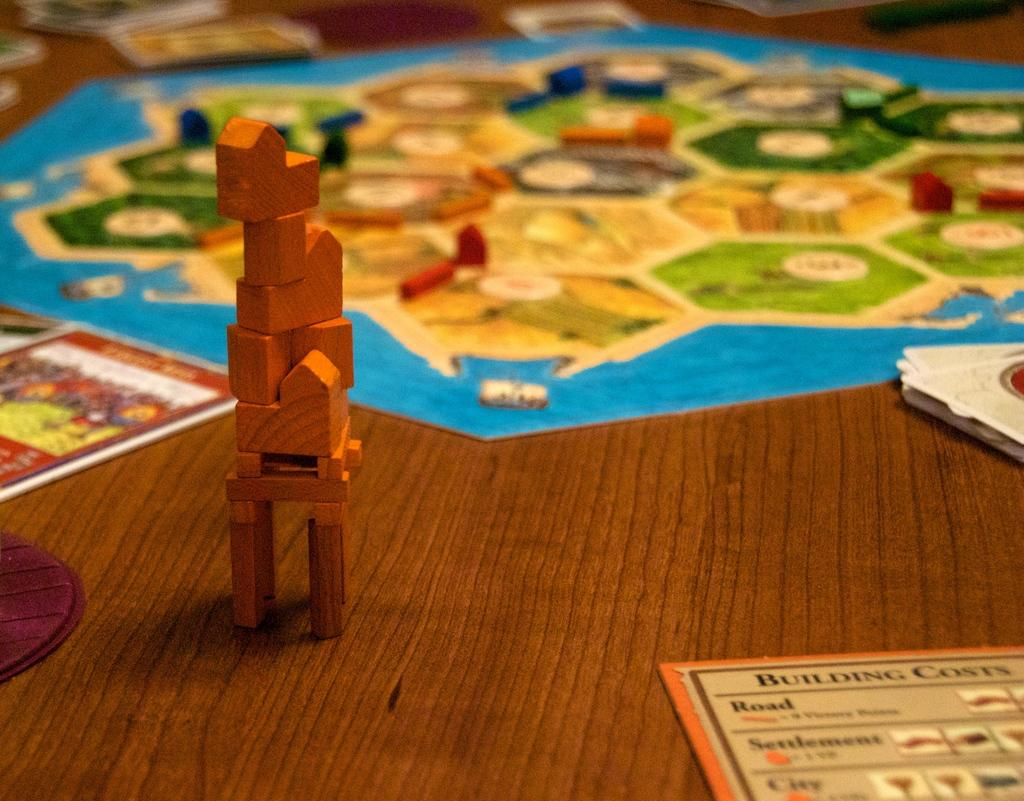Provide a one-sentence caption for the provided image. Board game with building pieces and instructions for Building Costs. 